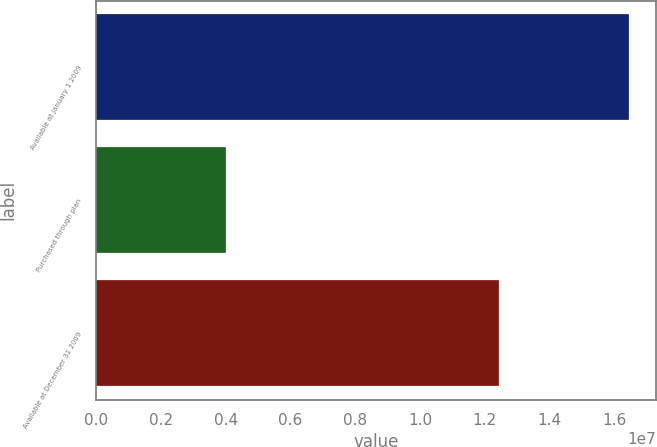<chart> <loc_0><loc_0><loc_500><loc_500><bar_chart><fcel>Available at January 1 2009<fcel>Purchased through plan<fcel>Available at December 31 2009<nl><fcel>1.64497e+07<fcel>4.01959e+06<fcel>1.24301e+07<nl></chart> 